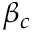Convert formula to latex. <formula><loc_0><loc_0><loc_500><loc_500>\beta _ { c }</formula> 